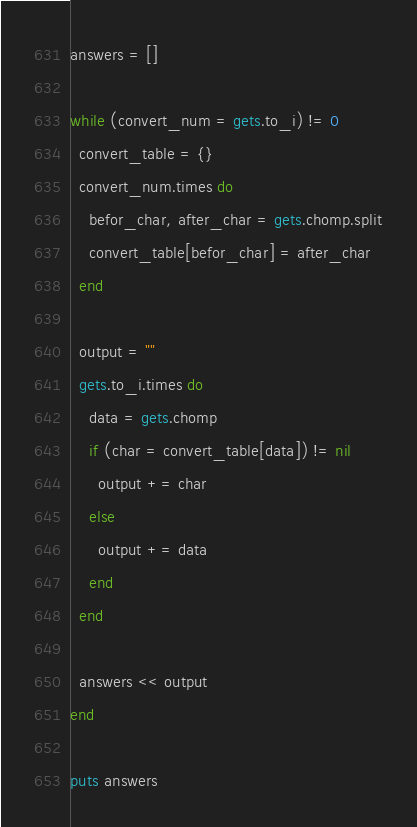<code> <loc_0><loc_0><loc_500><loc_500><_Ruby_>answers = []

while (convert_num = gets.to_i) != 0
  convert_table = {}
  convert_num.times do
    befor_char, after_char = gets.chomp.split
    convert_table[befor_char] = after_char
  end

  output = ""
  gets.to_i.times do
    data = gets.chomp
    if (char = convert_table[data]) != nil
      output += char
    else
      output += data
    end
  end

  answers << output
end

puts answers</code> 